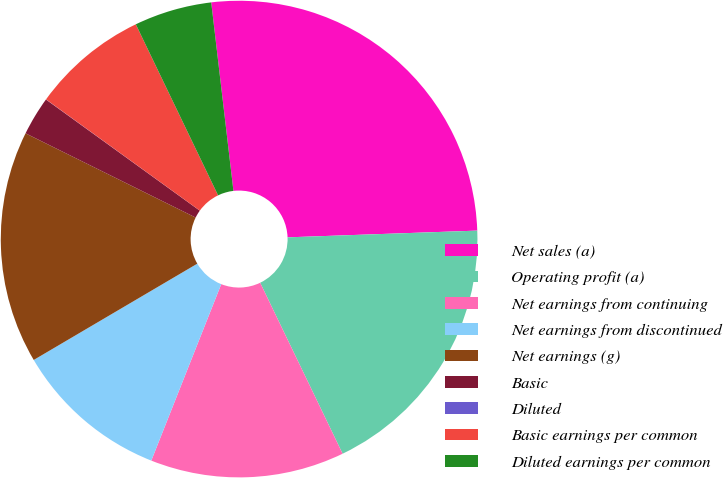Convert chart to OTSL. <chart><loc_0><loc_0><loc_500><loc_500><pie_chart><fcel>Net sales (a)<fcel>Operating profit (a)<fcel>Net earnings from continuing<fcel>Net earnings from discontinued<fcel>Net earnings (g)<fcel>Basic<fcel>Diluted<fcel>Basic earnings per common<fcel>Diluted earnings per common<nl><fcel>26.31%<fcel>18.42%<fcel>13.16%<fcel>10.53%<fcel>15.79%<fcel>2.64%<fcel>0.01%<fcel>7.9%<fcel>5.27%<nl></chart> 